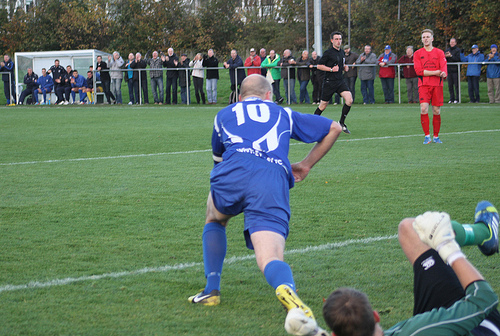<image>
Can you confirm if the man is next to the grass? No. The man is not positioned next to the grass. They are located in different areas of the scene. Is the player above the line? Yes. The player is positioned above the line in the vertical space, higher up in the scene. 